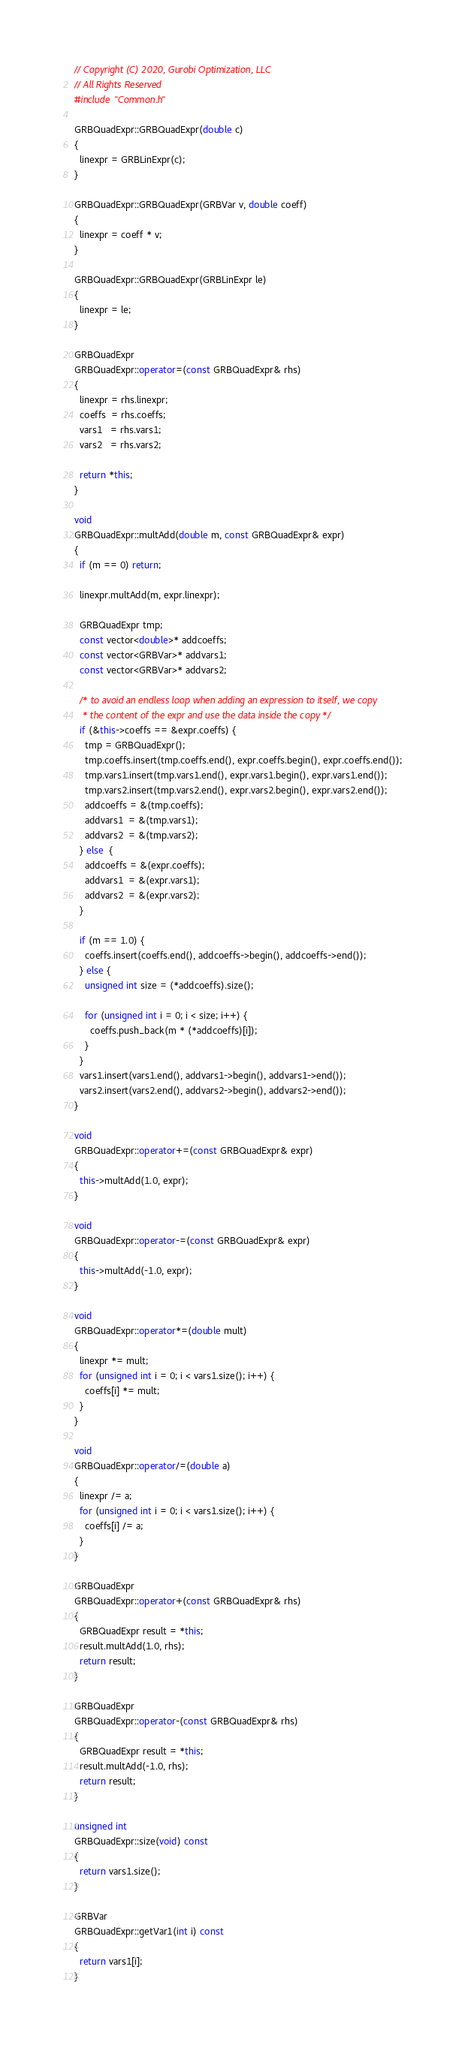<code> <loc_0><loc_0><loc_500><loc_500><_C++_>// Copyright (C) 2020, Gurobi Optimization, LLC
// All Rights Reserved
#include "Common.h"

GRBQuadExpr::GRBQuadExpr(double c)
{
  linexpr = GRBLinExpr(c);
}

GRBQuadExpr::GRBQuadExpr(GRBVar v, double coeff)
{
  linexpr = coeff * v;
}

GRBQuadExpr::GRBQuadExpr(GRBLinExpr le)
{
  linexpr = le;
}

GRBQuadExpr
GRBQuadExpr::operator=(const GRBQuadExpr& rhs)
{
  linexpr = rhs.linexpr;
  coeffs  = rhs.coeffs;
  vars1   = rhs.vars1;
  vars2   = rhs.vars2;

  return *this;
}

void
GRBQuadExpr::multAdd(double m, const GRBQuadExpr& expr)
{
  if (m == 0) return;

  linexpr.multAdd(m, expr.linexpr);

  GRBQuadExpr tmp;
  const vector<double>* addcoeffs;
  const vector<GRBVar>* addvars1;
  const vector<GRBVar>* addvars2;

  /* to avoid an endless loop when adding an expression to itself, we copy
   * the content of the expr and use the data inside the copy */
  if (&this->coeffs == &expr.coeffs) {
    tmp = GRBQuadExpr();
    tmp.coeffs.insert(tmp.coeffs.end(), expr.coeffs.begin(), expr.coeffs.end());
    tmp.vars1.insert(tmp.vars1.end(), expr.vars1.begin(), expr.vars1.end());
    tmp.vars2.insert(tmp.vars2.end(), expr.vars2.begin(), expr.vars2.end());
    addcoeffs = &(tmp.coeffs);
    addvars1  = &(tmp.vars1);
    addvars2  = &(tmp.vars2);
  } else  {
    addcoeffs = &(expr.coeffs);
    addvars1  = &(expr.vars1);
    addvars2  = &(expr.vars2);
  }

  if (m == 1.0) {
    coeffs.insert(coeffs.end(), addcoeffs->begin(), addcoeffs->end());
  } else {
    unsigned int size = (*addcoeffs).size();

    for (unsigned int i = 0; i < size; i++) {
      coeffs.push_back(m * (*addcoeffs)[i]);
    }
  }
  vars1.insert(vars1.end(), addvars1->begin(), addvars1->end());
  vars2.insert(vars2.end(), addvars2->begin(), addvars2->end());
}

void
GRBQuadExpr::operator+=(const GRBQuadExpr& expr)
{
  this->multAdd(1.0, expr);
}

void
GRBQuadExpr::operator-=(const GRBQuadExpr& expr)
{
  this->multAdd(-1.0, expr);
}

void
GRBQuadExpr::operator*=(double mult)
{
  linexpr *= mult;
  for (unsigned int i = 0; i < vars1.size(); i++) {
    coeffs[i] *= mult;
  }
}

void
GRBQuadExpr::operator/=(double a)
{
  linexpr /= a;
  for (unsigned int i = 0; i < vars1.size(); i++) {
    coeffs[i] /= a;
  }
}

GRBQuadExpr
GRBQuadExpr::operator+(const GRBQuadExpr& rhs)
{
  GRBQuadExpr result = *this;
  result.multAdd(1.0, rhs);
  return result;
}

GRBQuadExpr
GRBQuadExpr::operator-(const GRBQuadExpr& rhs)
{
  GRBQuadExpr result = *this;
  result.multAdd(-1.0, rhs);
  return result;
}

unsigned int
GRBQuadExpr::size(void) const
{
  return vars1.size();
}

GRBVar
GRBQuadExpr::getVar1(int i) const
{
  return vars1[i];
}
</code> 